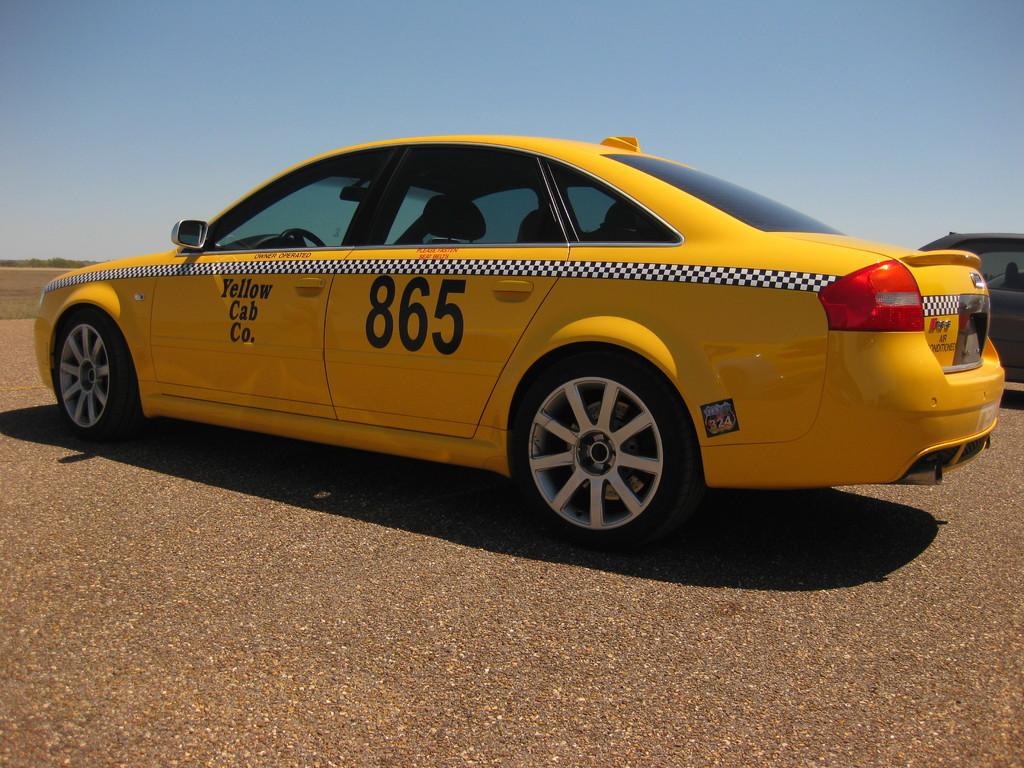What number is this cab?
Give a very brief answer. 865. What cab company is this taxi from?
Make the answer very short. Yellow cab co. 